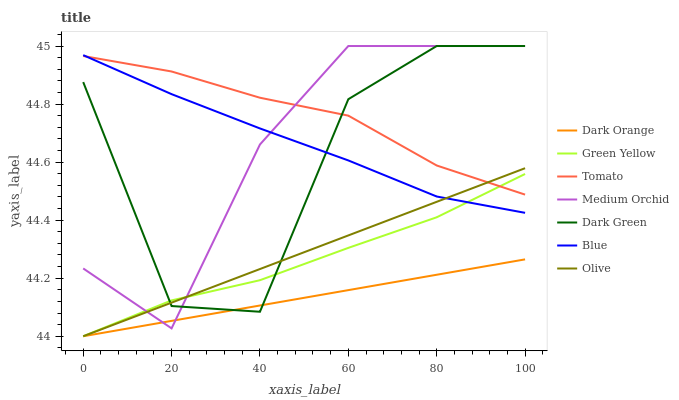Does Dark Orange have the minimum area under the curve?
Answer yes or no. Yes. Does Tomato have the maximum area under the curve?
Answer yes or no. Yes. Does Medium Orchid have the minimum area under the curve?
Answer yes or no. No. Does Medium Orchid have the maximum area under the curve?
Answer yes or no. No. Is Dark Orange the smoothest?
Answer yes or no. Yes. Is Dark Green the roughest?
Answer yes or no. Yes. Is Medium Orchid the smoothest?
Answer yes or no. No. Is Medium Orchid the roughest?
Answer yes or no. No. Does Medium Orchid have the lowest value?
Answer yes or no. No. Does Dark Green have the highest value?
Answer yes or no. Yes. Does Dark Orange have the highest value?
Answer yes or no. No. Is Dark Orange less than Tomato?
Answer yes or no. Yes. Is Tomato greater than Dark Orange?
Answer yes or no. Yes. Does Dark Orange intersect Tomato?
Answer yes or no. No. 